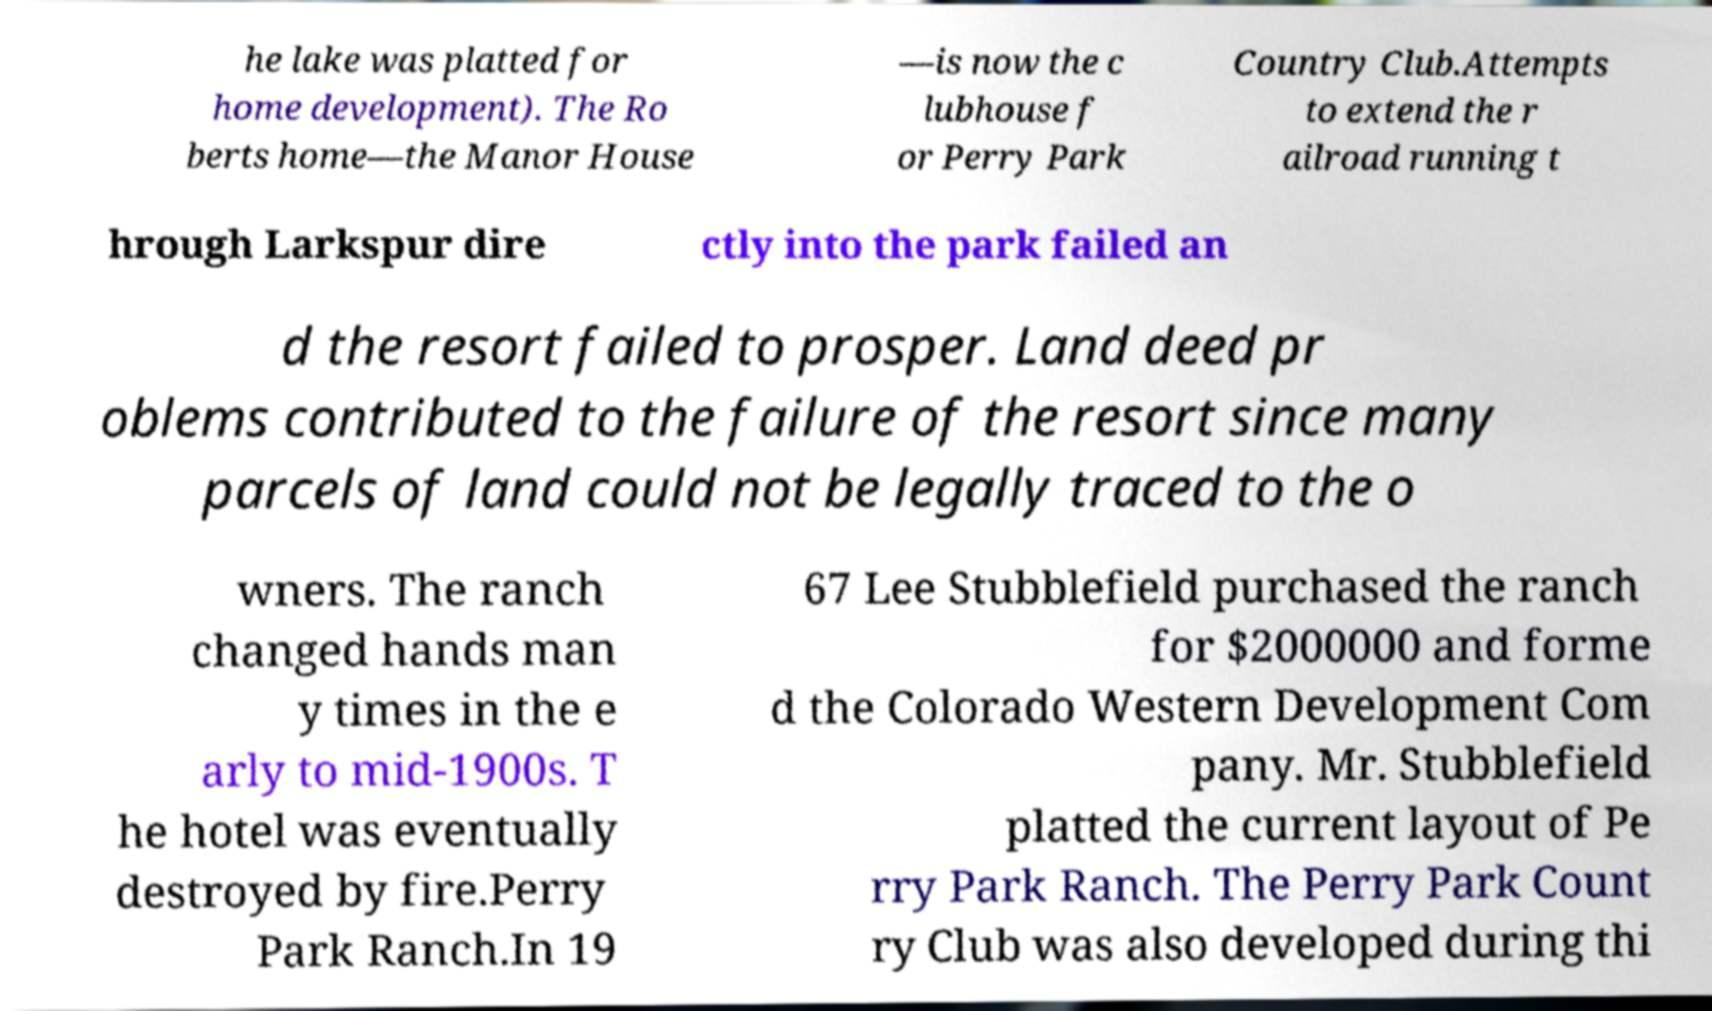Could you extract and type out the text from this image? he lake was platted for home development). The Ro berts home—the Manor House —is now the c lubhouse f or Perry Park Country Club.Attempts to extend the r ailroad running t hrough Larkspur dire ctly into the park failed an d the resort failed to prosper. Land deed pr oblems contributed to the failure of the resort since many parcels of land could not be legally traced to the o wners. The ranch changed hands man y times in the e arly to mid-1900s. T he hotel was eventually destroyed by fire.Perry Park Ranch.In 19 67 Lee Stubblefield purchased the ranch for $2000000 and forme d the Colorado Western Development Com pany. Mr. Stubblefield platted the current layout of Pe rry Park Ranch. The Perry Park Count ry Club was also developed during thi 